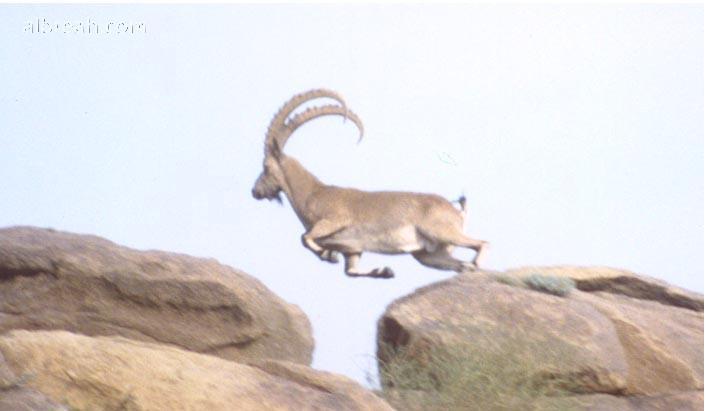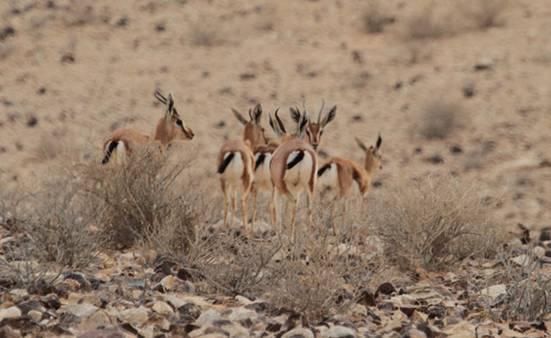The first image is the image on the left, the second image is the image on the right. Evaluate the accuracy of this statement regarding the images: "There are more than four animals in the image on the left.". Is it true? Answer yes or no. No. The first image is the image on the left, the second image is the image on the right. For the images displayed, is the sentence "A majority of horned animals in one image are rear-facing, and the other image shows a rocky ledge that drops off." factually correct? Answer yes or no. Yes. 